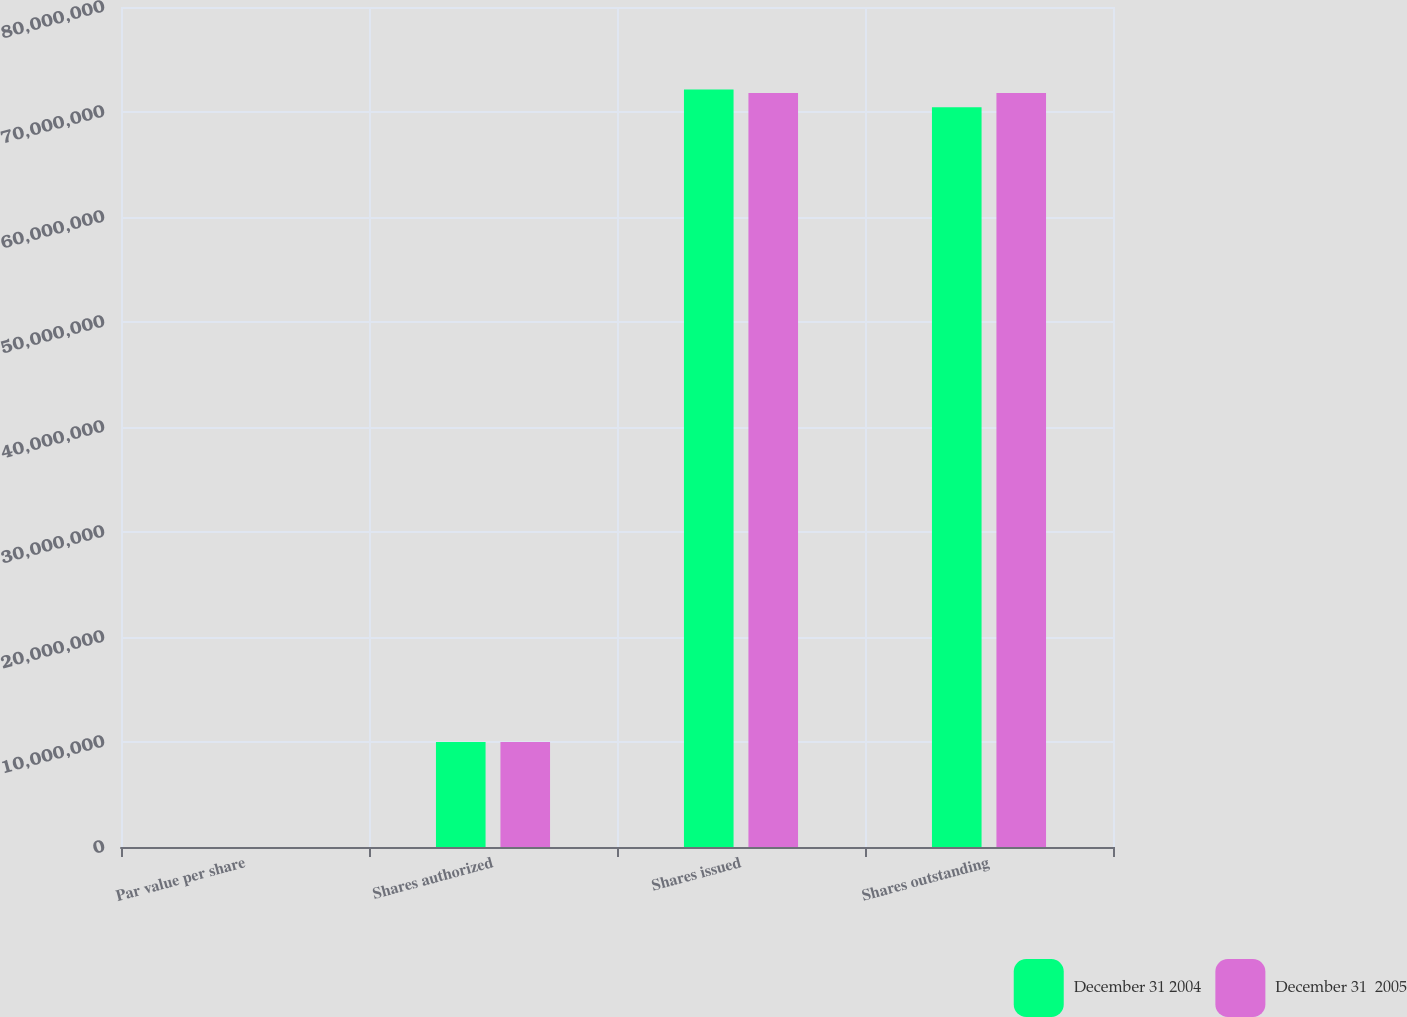Convert chart. <chart><loc_0><loc_0><loc_500><loc_500><stacked_bar_chart><ecel><fcel>Par value per share<fcel>Shares authorized<fcel>Shares issued<fcel>Shares outstanding<nl><fcel>December 31 2004<fcel>0.01<fcel>1e+07<fcel>7.21519e+07<fcel>7.04511e+07<nl><fcel>December 31  2005<fcel>0.01<fcel>1e+07<fcel>7.18198e+07<fcel>7.18198e+07<nl></chart> 